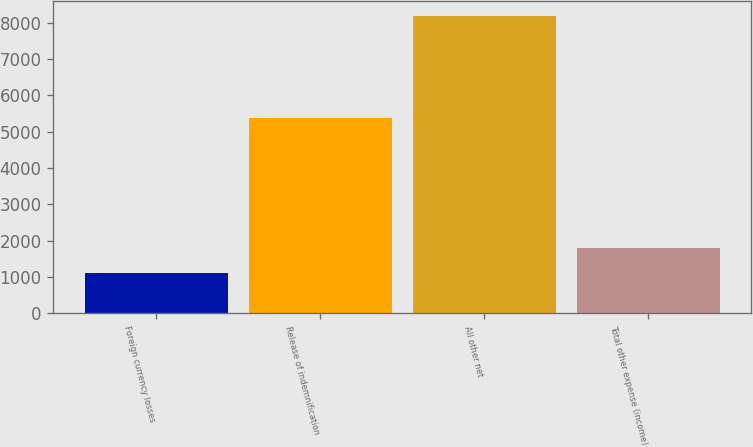Convert chart to OTSL. <chart><loc_0><loc_0><loc_500><loc_500><bar_chart><fcel>Foreign currency losses<fcel>Release of indemnification<fcel>All other net<fcel>Total other expense (income)<nl><fcel>1099<fcel>5371<fcel>8199<fcel>1809<nl></chart> 